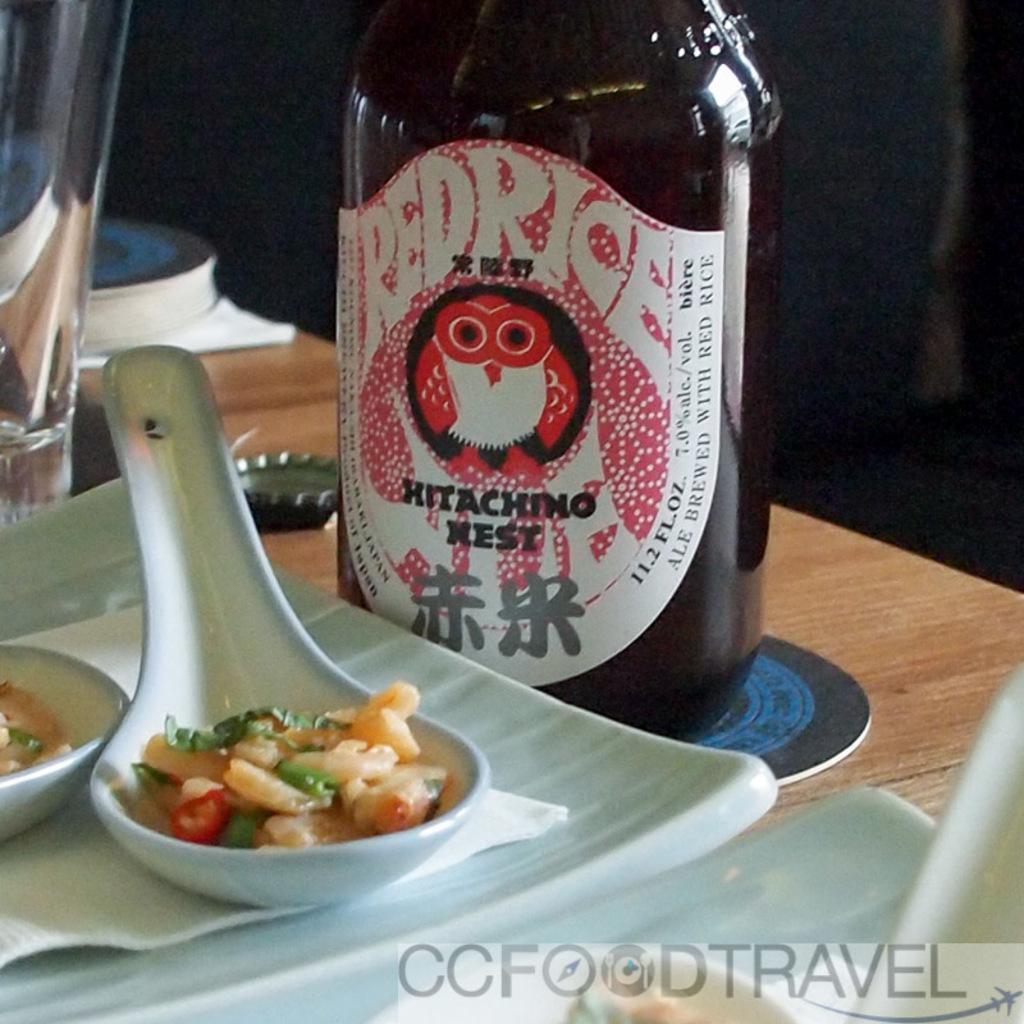Please provide a concise description of this image. In this image, we can see a table, there are two white color plates on the table, there is a white color spoon in the plate, there is a bottle kept on the table. 